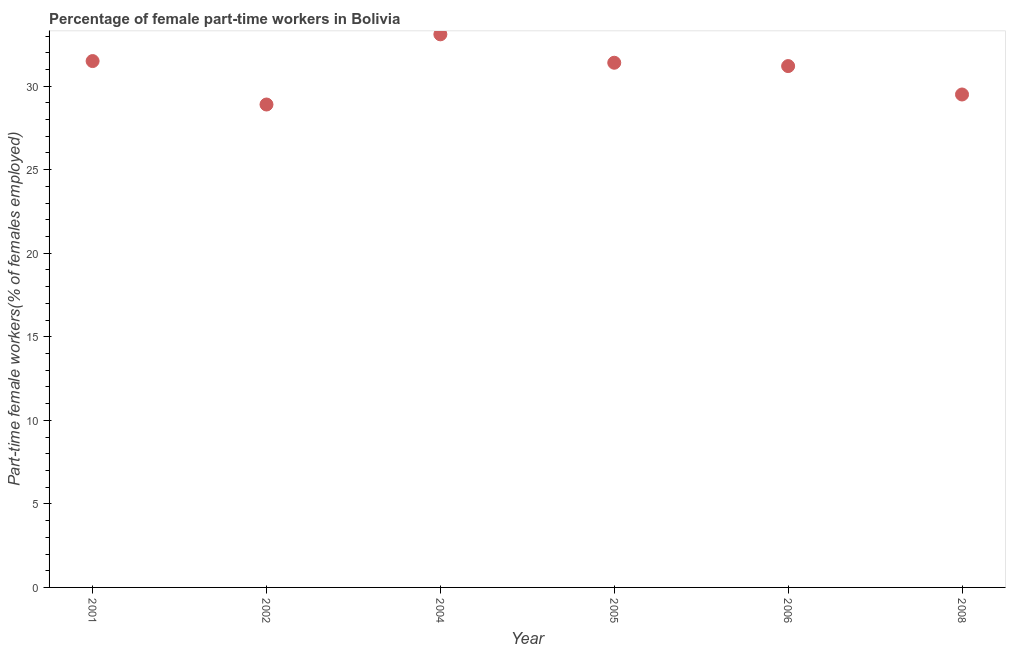What is the percentage of part-time female workers in 2001?
Offer a very short reply. 31.5. Across all years, what is the maximum percentage of part-time female workers?
Give a very brief answer. 33.1. Across all years, what is the minimum percentage of part-time female workers?
Give a very brief answer. 28.9. In which year was the percentage of part-time female workers maximum?
Your answer should be very brief. 2004. In which year was the percentage of part-time female workers minimum?
Provide a short and direct response. 2002. What is the sum of the percentage of part-time female workers?
Provide a short and direct response. 185.6. What is the difference between the percentage of part-time female workers in 2004 and 2008?
Make the answer very short. 3.6. What is the average percentage of part-time female workers per year?
Provide a succinct answer. 30.93. What is the median percentage of part-time female workers?
Keep it short and to the point. 31.3. In how many years, is the percentage of part-time female workers greater than 6 %?
Offer a terse response. 6. Do a majority of the years between 2006 and 2002 (inclusive) have percentage of part-time female workers greater than 23 %?
Give a very brief answer. Yes. What is the ratio of the percentage of part-time female workers in 2006 to that in 2008?
Ensure brevity in your answer.  1.06. Is the difference between the percentage of part-time female workers in 2005 and 2008 greater than the difference between any two years?
Your answer should be very brief. No. What is the difference between the highest and the second highest percentage of part-time female workers?
Your answer should be compact. 1.6. What is the difference between the highest and the lowest percentage of part-time female workers?
Keep it short and to the point. 4.2. Does the percentage of part-time female workers monotonically increase over the years?
Provide a short and direct response. No. How many dotlines are there?
Ensure brevity in your answer.  1. Does the graph contain grids?
Offer a very short reply. No. What is the title of the graph?
Provide a succinct answer. Percentage of female part-time workers in Bolivia. What is the label or title of the X-axis?
Give a very brief answer. Year. What is the label or title of the Y-axis?
Ensure brevity in your answer.  Part-time female workers(% of females employed). What is the Part-time female workers(% of females employed) in 2001?
Keep it short and to the point. 31.5. What is the Part-time female workers(% of females employed) in 2002?
Your answer should be very brief. 28.9. What is the Part-time female workers(% of females employed) in 2004?
Your answer should be very brief. 33.1. What is the Part-time female workers(% of females employed) in 2005?
Keep it short and to the point. 31.4. What is the Part-time female workers(% of females employed) in 2006?
Your response must be concise. 31.2. What is the Part-time female workers(% of females employed) in 2008?
Provide a short and direct response. 29.5. What is the difference between the Part-time female workers(% of females employed) in 2001 and 2004?
Offer a terse response. -1.6. What is the difference between the Part-time female workers(% of females employed) in 2001 and 2005?
Provide a short and direct response. 0.1. What is the difference between the Part-time female workers(% of females employed) in 2001 and 2006?
Give a very brief answer. 0.3. What is the difference between the Part-time female workers(% of females employed) in 2001 and 2008?
Offer a very short reply. 2. What is the difference between the Part-time female workers(% of females employed) in 2002 and 2004?
Your response must be concise. -4.2. What is the difference between the Part-time female workers(% of females employed) in 2002 and 2005?
Your answer should be compact. -2.5. What is the difference between the Part-time female workers(% of females employed) in 2002 and 2006?
Ensure brevity in your answer.  -2.3. What is the difference between the Part-time female workers(% of females employed) in 2004 and 2005?
Your answer should be very brief. 1.7. What is the difference between the Part-time female workers(% of females employed) in 2004 and 2006?
Your answer should be compact. 1.9. What is the difference between the Part-time female workers(% of females employed) in 2004 and 2008?
Offer a very short reply. 3.6. What is the difference between the Part-time female workers(% of females employed) in 2005 and 2006?
Provide a short and direct response. 0.2. What is the ratio of the Part-time female workers(% of females employed) in 2001 to that in 2002?
Keep it short and to the point. 1.09. What is the ratio of the Part-time female workers(% of females employed) in 2001 to that in 2008?
Make the answer very short. 1.07. What is the ratio of the Part-time female workers(% of females employed) in 2002 to that in 2004?
Give a very brief answer. 0.87. What is the ratio of the Part-time female workers(% of females employed) in 2002 to that in 2005?
Your answer should be very brief. 0.92. What is the ratio of the Part-time female workers(% of females employed) in 2002 to that in 2006?
Keep it short and to the point. 0.93. What is the ratio of the Part-time female workers(% of females employed) in 2004 to that in 2005?
Give a very brief answer. 1.05. What is the ratio of the Part-time female workers(% of females employed) in 2004 to that in 2006?
Make the answer very short. 1.06. What is the ratio of the Part-time female workers(% of females employed) in 2004 to that in 2008?
Ensure brevity in your answer.  1.12. What is the ratio of the Part-time female workers(% of females employed) in 2005 to that in 2006?
Your answer should be very brief. 1.01. What is the ratio of the Part-time female workers(% of females employed) in 2005 to that in 2008?
Provide a succinct answer. 1.06. What is the ratio of the Part-time female workers(% of females employed) in 2006 to that in 2008?
Your answer should be compact. 1.06. 